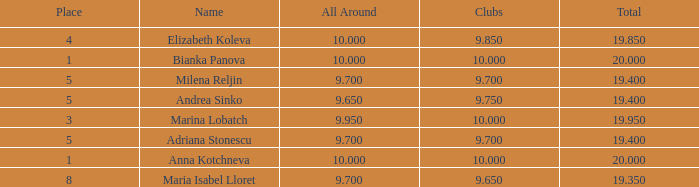What total has 10 as the clubs, with a place greater than 1? 19.95. 